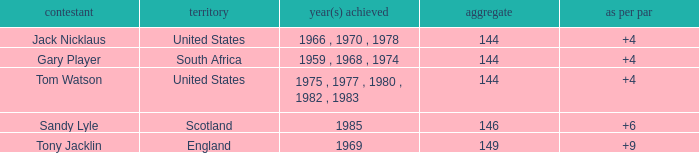What was England's total? 149.0. 